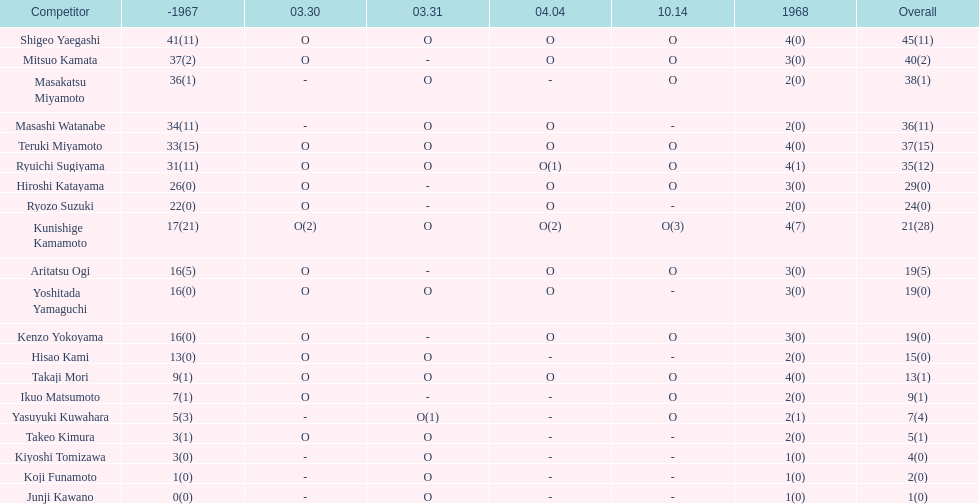Did mitsuo kamata have more than 40 total points? No. 